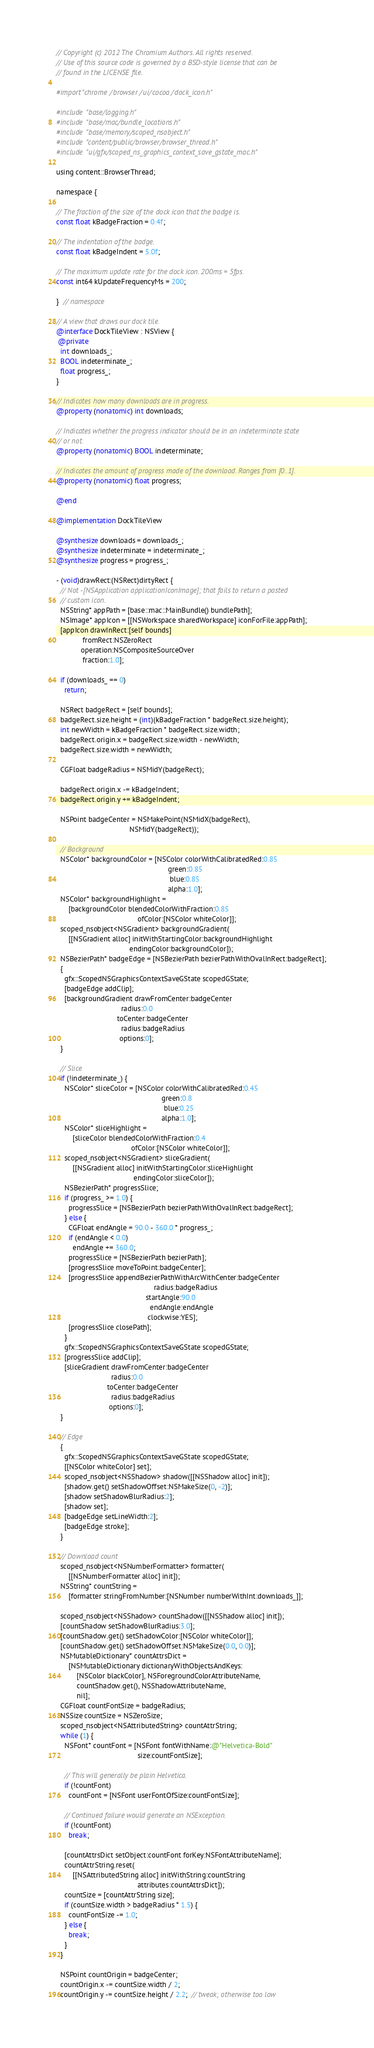Convert code to text. <code><loc_0><loc_0><loc_500><loc_500><_ObjectiveC_>// Copyright (c) 2012 The Chromium Authors. All rights reserved.
// Use of this source code is governed by a BSD-style license that can be
// found in the LICENSE file.

#import "chrome/browser/ui/cocoa/dock_icon.h"

#include "base/logging.h"
#include "base/mac/bundle_locations.h"
#include "base/memory/scoped_nsobject.h"
#include "content/public/browser/browser_thread.h"
#include "ui/gfx/scoped_ns_graphics_context_save_gstate_mac.h"

using content::BrowserThread;

namespace {

// The fraction of the size of the dock icon that the badge is.
const float kBadgeFraction = 0.4f;

// The indentation of the badge.
const float kBadgeIndent = 5.0f;

// The maximum update rate for the dock icon. 200ms = 5fps.
const int64 kUpdateFrequencyMs = 200;

}  // namespace

// A view that draws our dock tile.
@interface DockTileView : NSView {
 @private
  int downloads_;
  BOOL indeterminate_;
  float progress_;
}

// Indicates how many downloads are in progress.
@property (nonatomic) int downloads;

// Indicates whether the progress indicator should be in an indeterminate state
// or not.
@property (nonatomic) BOOL indeterminate;

// Indicates the amount of progress made of the download. Ranges from [0..1].
@property (nonatomic) float progress;

@end

@implementation DockTileView

@synthesize downloads = downloads_;
@synthesize indeterminate = indeterminate_;
@synthesize progress = progress_;

- (void)drawRect:(NSRect)dirtyRect {
  // Not -[NSApplication applicationIconImage]; that fails to return a pasted
  // custom icon.
  NSString* appPath = [base::mac::MainBundle() bundlePath];
  NSImage* appIcon = [[NSWorkspace sharedWorkspace] iconForFile:appPath];
  [appIcon drawInRect:[self bounds]
             fromRect:NSZeroRect
            operation:NSCompositeSourceOver
             fraction:1.0];

  if (downloads_ == 0)
    return;

  NSRect badgeRect = [self bounds];
  badgeRect.size.height = (int)(kBadgeFraction * badgeRect.size.height);
  int newWidth = kBadgeFraction * badgeRect.size.width;
  badgeRect.origin.x = badgeRect.size.width - newWidth;
  badgeRect.size.width = newWidth;

  CGFloat badgeRadius = NSMidY(badgeRect);

  badgeRect.origin.x -= kBadgeIndent;
  badgeRect.origin.y += kBadgeIndent;

  NSPoint badgeCenter = NSMakePoint(NSMidX(badgeRect),
                                    NSMidY(badgeRect));

  // Background
  NSColor* backgroundColor = [NSColor colorWithCalibratedRed:0.85
                                                       green:0.85
                                                        blue:0.85
                                                       alpha:1.0];
  NSColor* backgroundHighlight =
      [backgroundColor blendedColorWithFraction:0.85
                                        ofColor:[NSColor whiteColor]];
  scoped_nsobject<NSGradient> backgroundGradient(
      [[NSGradient alloc] initWithStartingColor:backgroundHighlight
                                    endingColor:backgroundColor]);
  NSBezierPath* badgeEdge = [NSBezierPath bezierPathWithOvalInRect:badgeRect];
  {
    gfx::ScopedNSGraphicsContextSaveGState scopedGState;
    [badgeEdge addClip];
    [backgroundGradient drawFromCenter:badgeCenter
                                radius:0.0
                              toCenter:badgeCenter
                                radius:badgeRadius
                               options:0];
  }

  // Slice
  if (!indeterminate_) {
    NSColor* sliceColor = [NSColor colorWithCalibratedRed:0.45
                                                    green:0.8
                                                     blue:0.25
                                                    alpha:1.0];
    NSColor* sliceHighlight =
        [sliceColor blendedColorWithFraction:0.4
                                     ofColor:[NSColor whiteColor]];
    scoped_nsobject<NSGradient> sliceGradient(
        [[NSGradient alloc] initWithStartingColor:sliceHighlight
                                      endingColor:sliceColor]);
    NSBezierPath* progressSlice;
    if (progress_ >= 1.0) {
      progressSlice = [NSBezierPath bezierPathWithOvalInRect:badgeRect];
    } else {
      CGFloat endAngle = 90.0 - 360.0 * progress_;
      if (endAngle < 0.0)
        endAngle += 360.0;
      progressSlice = [NSBezierPath bezierPath];
      [progressSlice moveToPoint:badgeCenter];
      [progressSlice appendBezierPathWithArcWithCenter:badgeCenter
                                                radius:badgeRadius
                                            startAngle:90.0
                                              endAngle:endAngle
                                             clockwise:YES];
      [progressSlice closePath];
    }
    gfx::ScopedNSGraphicsContextSaveGState scopedGState;
    [progressSlice addClip];
    [sliceGradient drawFromCenter:badgeCenter
                           radius:0.0
                         toCenter:badgeCenter
                           radius:badgeRadius
                          options:0];
  }

  // Edge
  {
    gfx::ScopedNSGraphicsContextSaveGState scopedGState;
    [[NSColor whiteColor] set];
    scoped_nsobject<NSShadow> shadow([[NSShadow alloc] init]);
    [shadow.get() setShadowOffset:NSMakeSize(0, -2)];
    [shadow setShadowBlurRadius:2];
    [shadow set];
    [badgeEdge setLineWidth:2];
    [badgeEdge stroke];
  }

  // Download count
  scoped_nsobject<NSNumberFormatter> formatter(
      [[NSNumberFormatter alloc] init]);
  NSString* countString =
      [formatter stringFromNumber:[NSNumber numberWithInt:downloads_]];

  scoped_nsobject<NSShadow> countShadow([[NSShadow alloc] init]);
  [countShadow setShadowBlurRadius:3.0];
  [countShadow.get() setShadowColor:[NSColor whiteColor]];
  [countShadow.get() setShadowOffset:NSMakeSize(0.0, 0.0)];
  NSMutableDictionary* countAttrsDict =
      [NSMutableDictionary dictionaryWithObjectsAndKeys:
          [NSColor blackColor], NSForegroundColorAttributeName,
          countShadow.get(), NSShadowAttributeName,
          nil];
  CGFloat countFontSize = badgeRadius;
  NSSize countSize = NSZeroSize;
  scoped_nsobject<NSAttributedString> countAttrString;
  while (1) {
    NSFont* countFont = [NSFont fontWithName:@"Helvetica-Bold"
                                        size:countFontSize];

    // This will generally be plain Helvetica.
    if (!countFont)
      countFont = [NSFont userFontOfSize:countFontSize];

    // Continued failure would generate an NSException.
    if (!countFont)
      break;

    [countAttrsDict setObject:countFont forKey:NSFontAttributeName];
    countAttrString.reset(
        [[NSAttributedString alloc] initWithString:countString
                                        attributes:countAttrsDict]);
    countSize = [countAttrString size];
    if (countSize.width > badgeRadius * 1.5) {
      countFontSize -= 1.0;
    } else {
      break;
    }
  }

  NSPoint countOrigin = badgeCenter;
  countOrigin.x -= countSize.width / 2;
  countOrigin.y -= countSize.height / 2.2;  // tweak; otherwise too low
</code> 